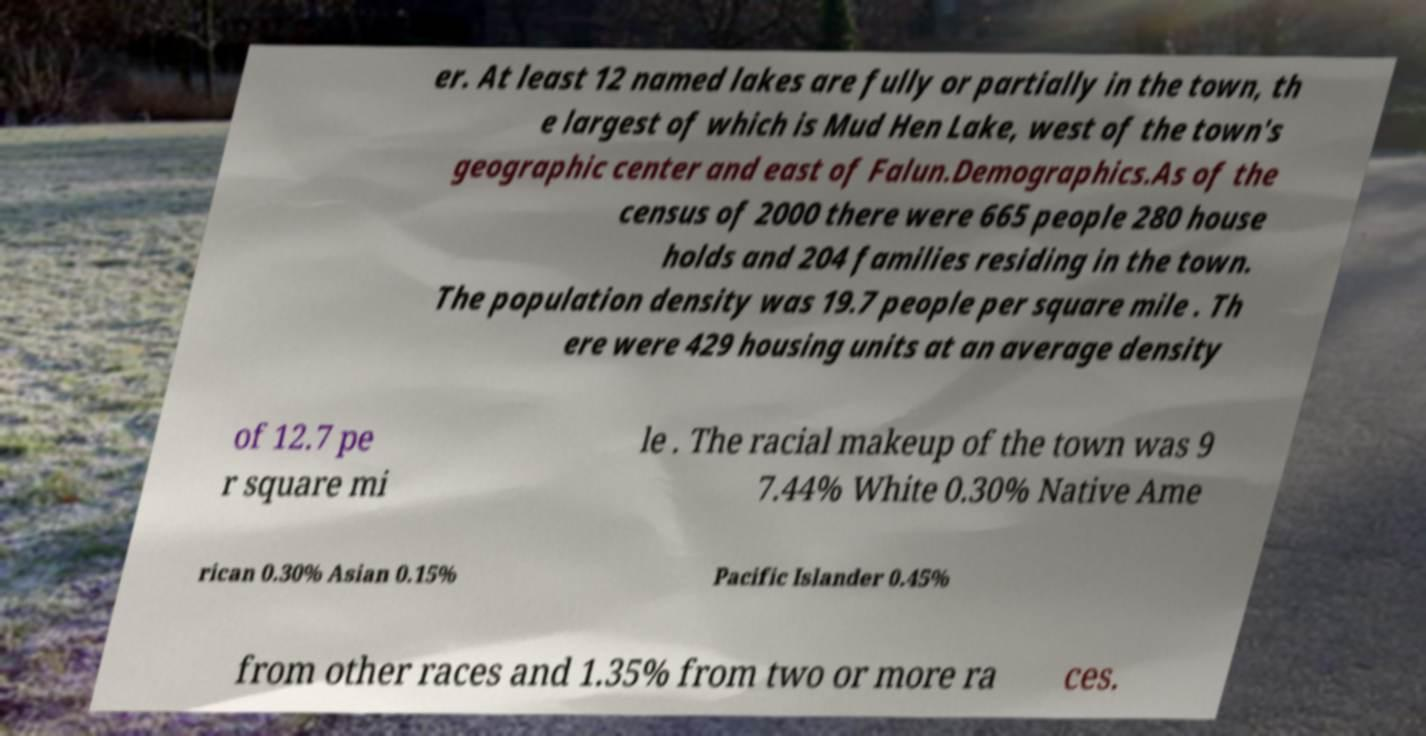There's text embedded in this image that I need extracted. Can you transcribe it verbatim? er. At least 12 named lakes are fully or partially in the town, th e largest of which is Mud Hen Lake, west of the town's geographic center and east of Falun.Demographics.As of the census of 2000 there were 665 people 280 house holds and 204 families residing in the town. The population density was 19.7 people per square mile . Th ere were 429 housing units at an average density of 12.7 pe r square mi le . The racial makeup of the town was 9 7.44% White 0.30% Native Ame rican 0.30% Asian 0.15% Pacific Islander 0.45% from other races and 1.35% from two or more ra ces. 